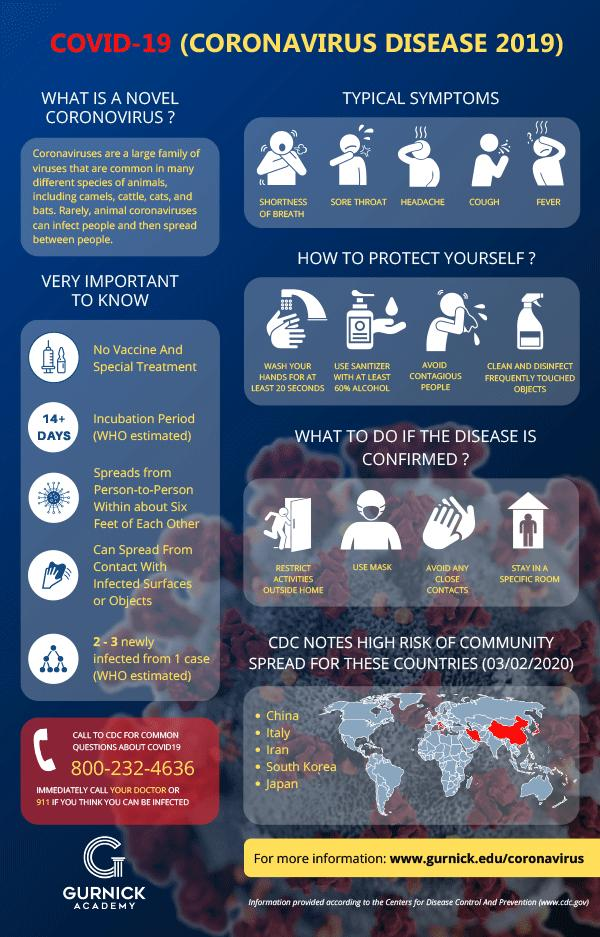Identify some key points in this picture. If corona is confirmed, the third point of action is to avoid any close contacts to prevent further spread of the virus. The fifth country listed in the high-risk category due to COVID-19 is Japan. It is important to clean hands for at least 20 seconds using soap and water in order to prevent the spread of COVID-19, also known as corona. This is the proper way to clean hands in order to prevent the spread of this viral illness. The color code used to identify countries in the high-risk category is black, white, yellow, and red, with red being the most severe level of risk. The animal coronaviruses are the type of coronavirus that may potentially be transmitted to humans. 